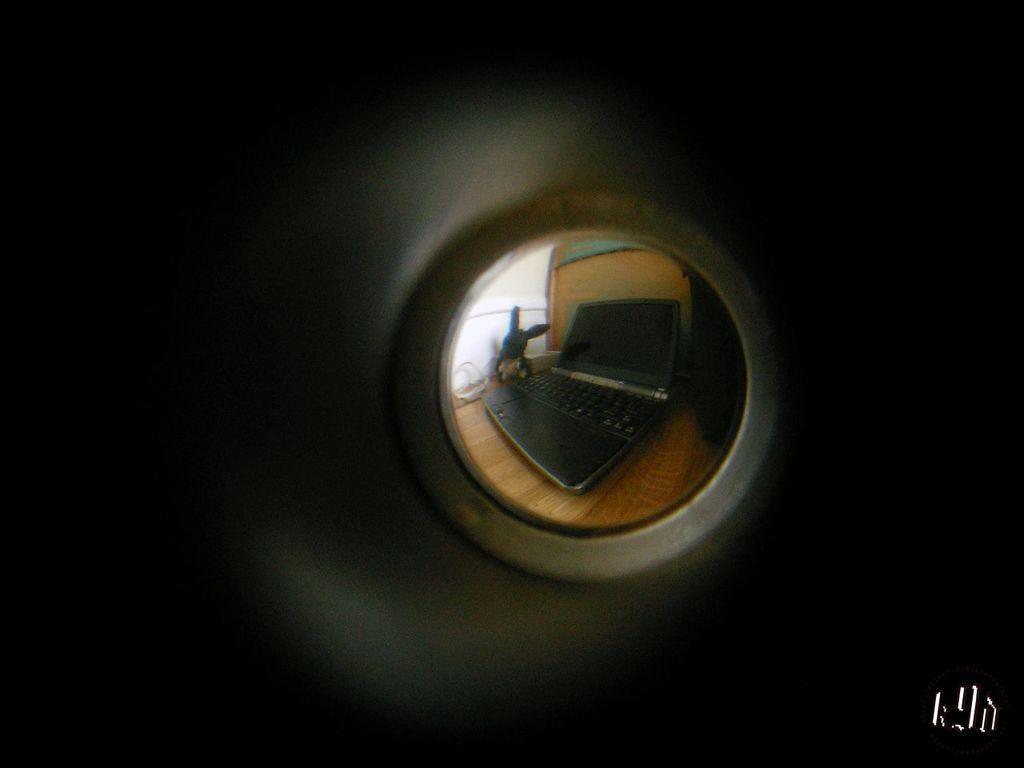What electronic device is visible in the image? There is a laptop in the image. What other object can be seen in the image? There is a toy in the image. On what type of surface are the objects placed? The objects are on a wooden surface. What can be observed about the background of the image? The background of the image is dark. What type of engine is visible in the image? There is no engine present in the image. What sign can be seen in the image? There is no sign present in the image. 